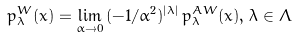Convert formula to latex. <formula><loc_0><loc_0><loc_500><loc_500>p _ { \lambda } ^ { W } ( x ) = \lim _ { \alpha \rightarrow 0 } \, ( - 1 / \alpha ^ { 2 } ) ^ { | \lambda | } \, p _ { \lambda } ^ { A W } ( x ) , \, \lambda \in \Lambda</formula> 